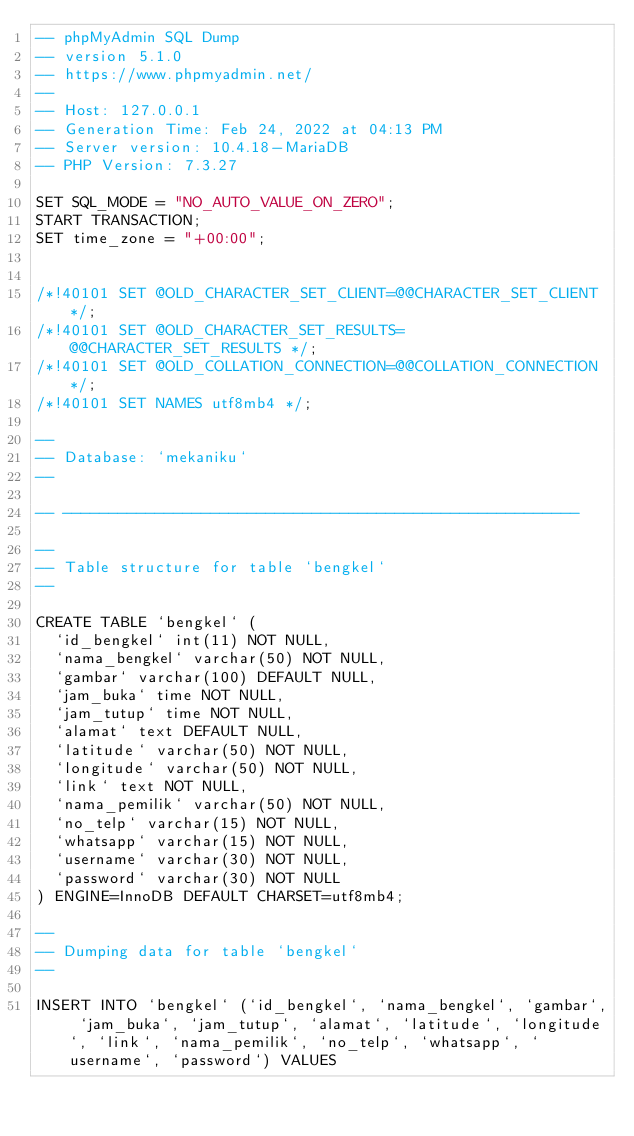<code> <loc_0><loc_0><loc_500><loc_500><_SQL_>-- phpMyAdmin SQL Dump
-- version 5.1.0
-- https://www.phpmyadmin.net/
--
-- Host: 127.0.0.1
-- Generation Time: Feb 24, 2022 at 04:13 PM
-- Server version: 10.4.18-MariaDB
-- PHP Version: 7.3.27

SET SQL_MODE = "NO_AUTO_VALUE_ON_ZERO";
START TRANSACTION;
SET time_zone = "+00:00";


/*!40101 SET @OLD_CHARACTER_SET_CLIENT=@@CHARACTER_SET_CLIENT */;
/*!40101 SET @OLD_CHARACTER_SET_RESULTS=@@CHARACTER_SET_RESULTS */;
/*!40101 SET @OLD_COLLATION_CONNECTION=@@COLLATION_CONNECTION */;
/*!40101 SET NAMES utf8mb4 */;

--
-- Database: `mekaniku`
--

-- --------------------------------------------------------

--
-- Table structure for table `bengkel`
--

CREATE TABLE `bengkel` (
  `id_bengkel` int(11) NOT NULL,
  `nama_bengkel` varchar(50) NOT NULL,
  `gambar` varchar(100) DEFAULT NULL,
  `jam_buka` time NOT NULL,
  `jam_tutup` time NOT NULL,
  `alamat` text DEFAULT NULL,
  `latitude` varchar(50) NOT NULL,
  `longitude` varchar(50) NOT NULL,
  `link` text NOT NULL,
  `nama_pemilik` varchar(50) NOT NULL,
  `no_telp` varchar(15) NOT NULL,
  `whatsapp` varchar(15) NOT NULL,
  `username` varchar(30) NOT NULL,
  `password` varchar(30) NOT NULL
) ENGINE=InnoDB DEFAULT CHARSET=utf8mb4;

--
-- Dumping data for table `bengkel`
--

INSERT INTO `bengkel` (`id_bengkel`, `nama_bengkel`, `gambar`, `jam_buka`, `jam_tutup`, `alamat`, `latitude`, `longitude`, `link`, `nama_pemilik`, `no_telp`, `whatsapp`, `username`, `password`) VALUES</code> 